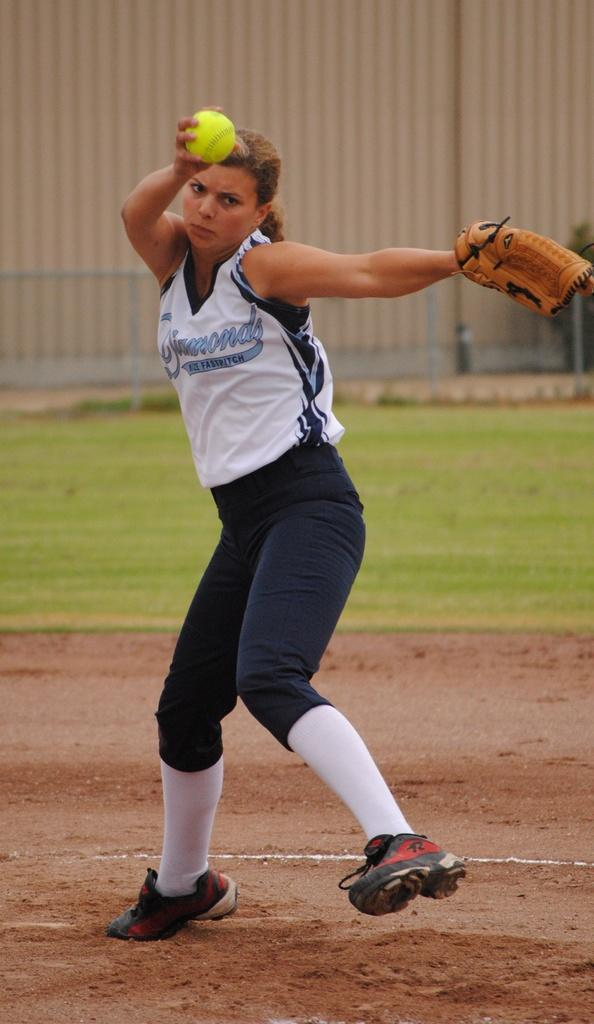<image>
Provide a brief description of the given image. The girl's blue and white jersey says "fastpitch" on it. 